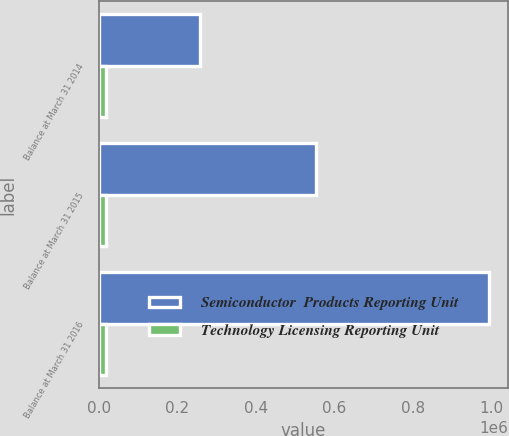Convert chart to OTSL. <chart><loc_0><loc_0><loc_500><loc_500><stacked_bar_chart><ecel><fcel>Balance at March 31 2014<fcel>Balance at March 31 2015<fcel>Balance at March 31 2016<nl><fcel>Semiconductor  Products Reporting Unit<fcel>256897<fcel>552071<fcel>993452<nl><fcel>Technology Licensing Reporting Unit<fcel>19200<fcel>19200<fcel>19200<nl></chart> 